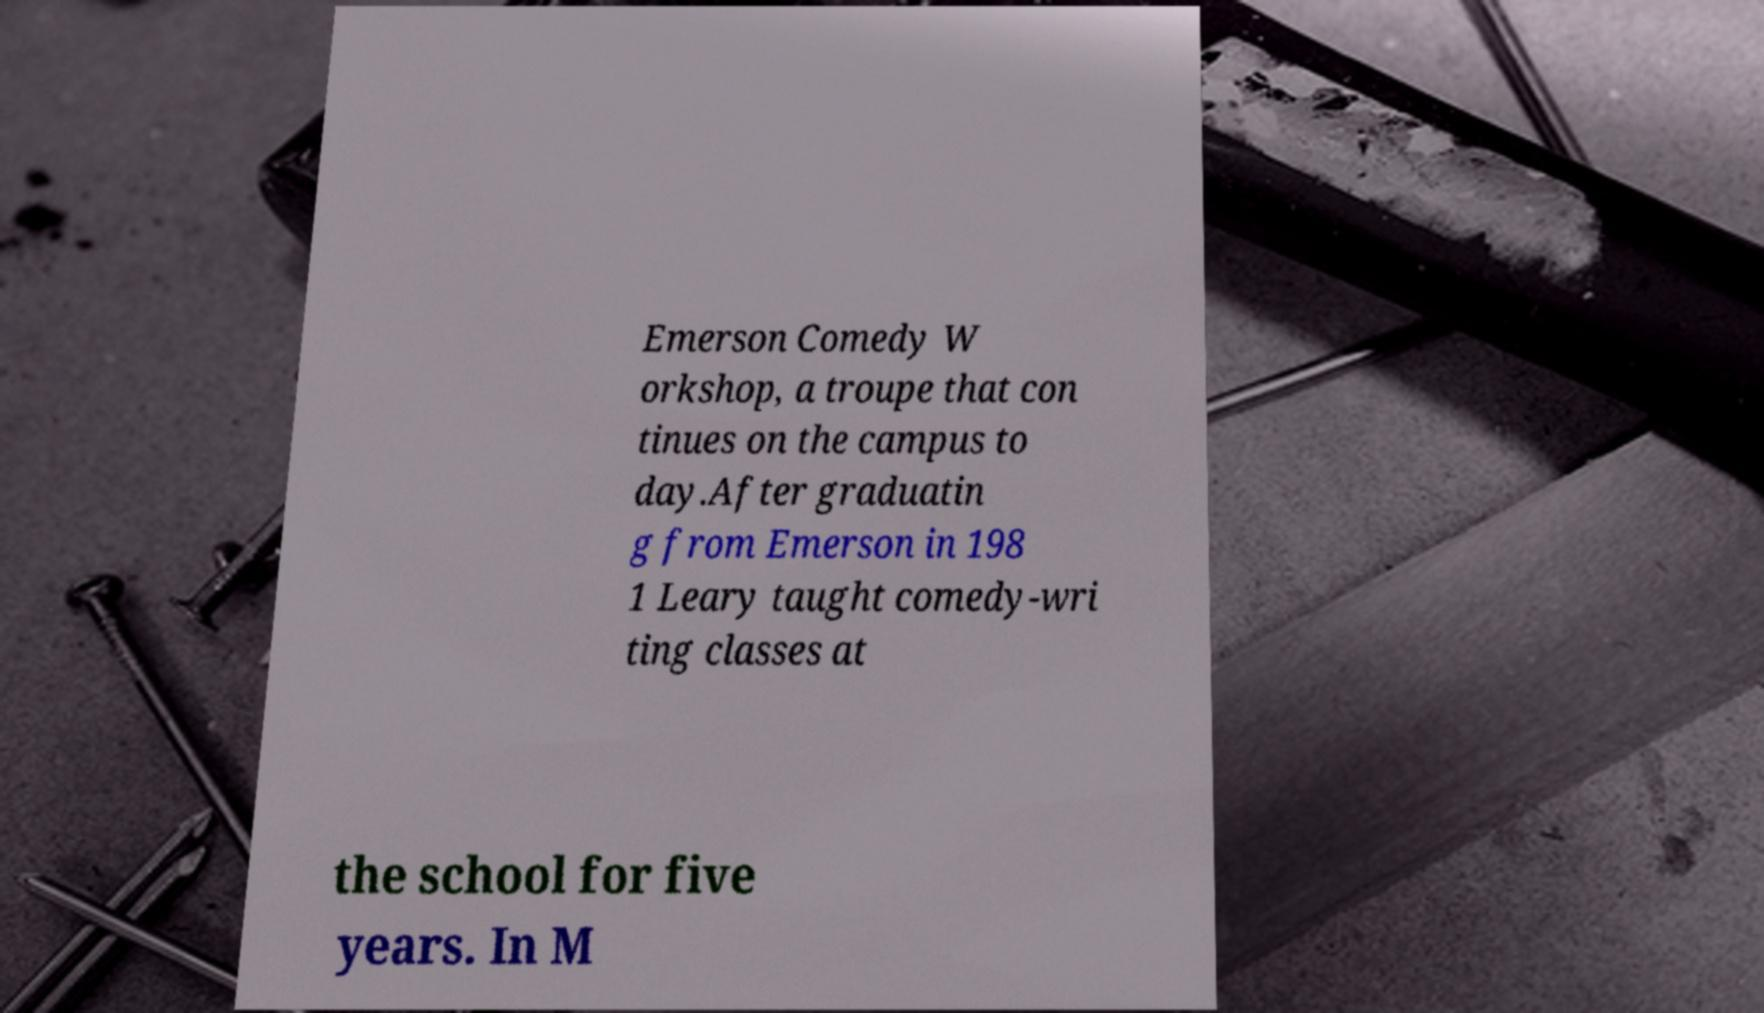I need the written content from this picture converted into text. Can you do that? Emerson Comedy W orkshop, a troupe that con tinues on the campus to day.After graduatin g from Emerson in 198 1 Leary taught comedy-wri ting classes at the school for five years. In M 